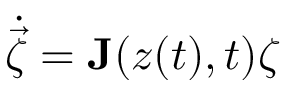<formula> <loc_0><loc_0><loc_500><loc_500>\dot { \vec { \zeta } } = J ( z ( t ) , t ) \zeta</formula> 